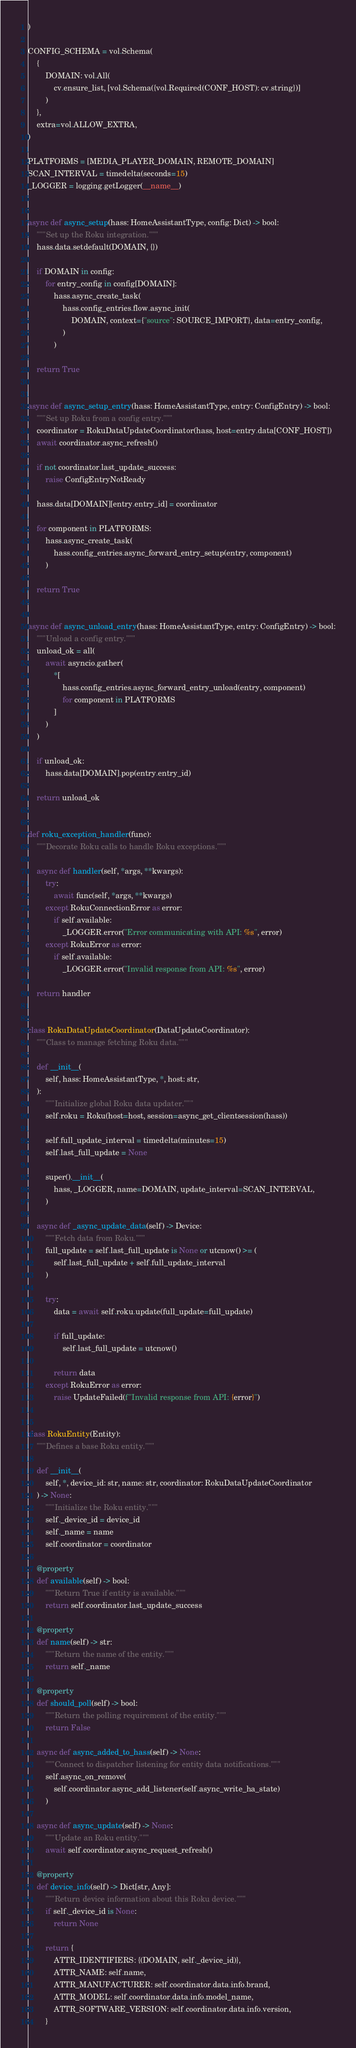<code> <loc_0><loc_0><loc_500><loc_500><_Python_>)

CONFIG_SCHEMA = vol.Schema(
    {
        DOMAIN: vol.All(
            cv.ensure_list, [vol.Schema({vol.Required(CONF_HOST): cv.string})]
        )
    },
    extra=vol.ALLOW_EXTRA,
)

PLATFORMS = [MEDIA_PLAYER_DOMAIN, REMOTE_DOMAIN]
SCAN_INTERVAL = timedelta(seconds=15)
_LOGGER = logging.getLogger(__name__)


async def async_setup(hass: HomeAssistantType, config: Dict) -> bool:
    """Set up the Roku integration."""
    hass.data.setdefault(DOMAIN, {})

    if DOMAIN in config:
        for entry_config in config[DOMAIN]:
            hass.async_create_task(
                hass.config_entries.flow.async_init(
                    DOMAIN, context={"source": SOURCE_IMPORT}, data=entry_config,
                )
            )

    return True


async def async_setup_entry(hass: HomeAssistantType, entry: ConfigEntry) -> bool:
    """Set up Roku from a config entry."""
    coordinator = RokuDataUpdateCoordinator(hass, host=entry.data[CONF_HOST])
    await coordinator.async_refresh()

    if not coordinator.last_update_success:
        raise ConfigEntryNotReady

    hass.data[DOMAIN][entry.entry_id] = coordinator

    for component in PLATFORMS:
        hass.async_create_task(
            hass.config_entries.async_forward_entry_setup(entry, component)
        )

    return True


async def async_unload_entry(hass: HomeAssistantType, entry: ConfigEntry) -> bool:
    """Unload a config entry."""
    unload_ok = all(
        await asyncio.gather(
            *[
                hass.config_entries.async_forward_entry_unload(entry, component)
                for component in PLATFORMS
            ]
        )
    )

    if unload_ok:
        hass.data[DOMAIN].pop(entry.entry_id)

    return unload_ok


def roku_exception_handler(func):
    """Decorate Roku calls to handle Roku exceptions."""

    async def handler(self, *args, **kwargs):
        try:
            await func(self, *args, **kwargs)
        except RokuConnectionError as error:
            if self.available:
                _LOGGER.error("Error communicating with API: %s", error)
        except RokuError as error:
            if self.available:
                _LOGGER.error("Invalid response from API: %s", error)

    return handler


class RokuDataUpdateCoordinator(DataUpdateCoordinator):
    """Class to manage fetching Roku data."""

    def __init__(
        self, hass: HomeAssistantType, *, host: str,
    ):
        """Initialize global Roku data updater."""
        self.roku = Roku(host=host, session=async_get_clientsession(hass))

        self.full_update_interval = timedelta(minutes=15)
        self.last_full_update = None

        super().__init__(
            hass, _LOGGER, name=DOMAIN, update_interval=SCAN_INTERVAL,
        )

    async def _async_update_data(self) -> Device:
        """Fetch data from Roku."""
        full_update = self.last_full_update is None or utcnow() >= (
            self.last_full_update + self.full_update_interval
        )

        try:
            data = await self.roku.update(full_update=full_update)

            if full_update:
                self.last_full_update = utcnow()

            return data
        except RokuError as error:
            raise UpdateFailed(f"Invalid response from API: {error}")


class RokuEntity(Entity):
    """Defines a base Roku entity."""

    def __init__(
        self, *, device_id: str, name: str, coordinator: RokuDataUpdateCoordinator
    ) -> None:
        """Initialize the Roku entity."""
        self._device_id = device_id
        self._name = name
        self.coordinator = coordinator

    @property
    def available(self) -> bool:
        """Return True if entity is available."""
        return self.coordinator.last_update_success

    @property
    def name(self) -> str:
        """Return the name of the entity."""
        return self._name

    @property
    def should_poll(self) -> bool:
        """Return the polling requirement of the entity."""
        return False

    async def async_added_to_hass(self) -> None:
        """Connect to dispatcher listening for entity data notifications."""
        self.async_on_remove(
            self.coordinator.async_add_listener(self.async_write_ha_state)
        )

    async def async_update(self) -> None:
        """Update an Roku entity."""
        await self.coordinator.async_request_refresh()

    @property
    def device_info(self) -> Dict[str, Any]:
        """Return device information about this Roku device."""
        if self._device_id is None:
            return None

        return {
            ATTR_IDENTIFIERS: {(DOMAIN, self._device_id)},
            ATTR_NAME: self.name,
            ATTR_MANUFACTURER: self.coordinator.data.info.brand,
            ATTR_MODEL: self.coordinator.data.info.model_name,
            ATTR_SOFTWARE_VERSION: self.coordinator.data.info.version,
        }
</code> 